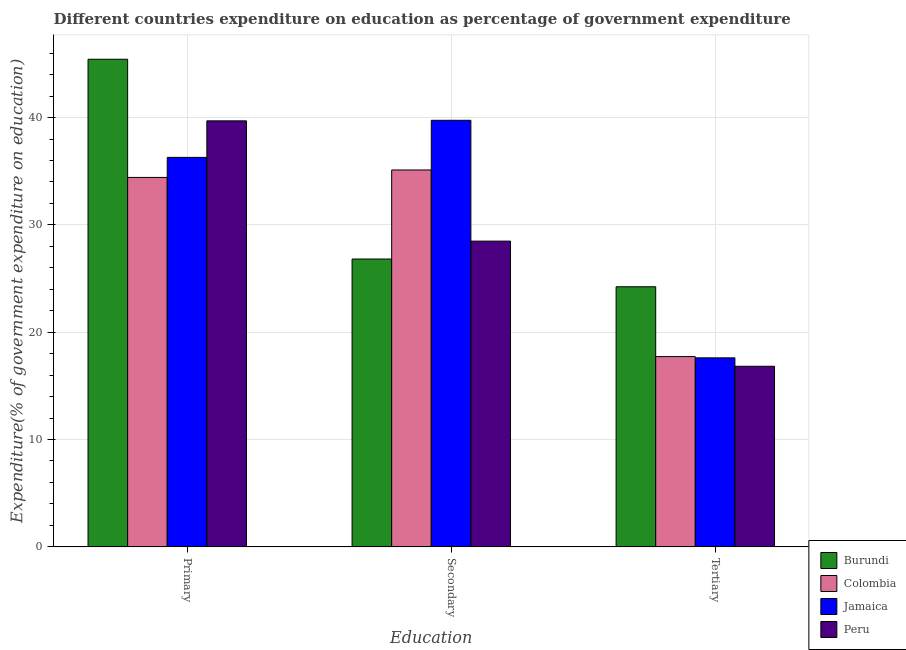How many different coloured bars are there?
Make the answer very short. 4. Are the number of bars on each tick of the X-axis equal?
Give a very brief answer. Yes. How many bars are there on the 3rd tick from the left?
Your response must be concise. 4. What is the label of the 3rd group of bars from the left?
Your answer should be compact. Tertiary. What is the expenditure on tertiary education in Peru?
Your answer should be very brief. 16.82. Across all countries, what is the maximum expenditure on primary education?
Your response must be concise. 45.43. Across all countries, what is the minimum expenditure on secondary education?
Provide a short and direct response. 26.82. In which country was the expenditure on tertiary education maximum?
Make the answer very short. Burundi. What is the total expenditure on primary education in the graph?
Give a very brief answer. 155.83. What is the difference between the expenditure on primary education in Colombia and that in Burundi?
Offer a very short reply. -11.01. What is the difference between the expenditure on tertiary education in Jamaica and the expenditure on primary education in Colombia?
Your answer should be very brief. -16.81. What is the average expenditure on primary education per country?
Ensure brevity in your answer.  38.96. What is the difference between the expenditure on primary education and expenditure on secondary education in Colombia?
Offer a very short reply. -0.69. What is the ratio of the expenditure on primary education in Colombia to that in Jamaica?
Offer a very short reply. 0.95. Is the expenditure on tertiary education in Colombia less than that in Burundi?
Keep it short and to the point. Yes. Is the difference between the expenditure on primary education in Peru and Burundi greater than the difference between the expenditure on tertiary education in Peru and Burundi?
Your answer should be compact. Yes. What is the difference between the highest and the second highest expenditure on primary education?
Offer a very short reply. 5.74. What is the difference between the highest and the lowest expenditure on secondary education?
Offer a terse response. 12.93. Is the sum of the expenditure on tertiary education in Burundi and Peru greater than the maximum expenditure on primary education across all countries?
Provide a succinct answer. No. What does the 4th bar from the left in Secondary represents?
Offer a terse response. Peru. What does the 2nd bar from the right in Tertiary represents?
Keep it short and to the point. Jamaica. How many countries are there in the graph?
Offer a very short reply. 4. Does the graph contain any zero values?
Your answer should be very brief. No. How are the legend labels stacked?
Give a very brief answer. Vertical. What is the title of the graph?
Make the answer very short. Different countries expenditure on education as percentage of government expenditure. What is the label or title of the X-axis?
Provide a short and direct response. Education. What is the label or title of the Y-axis?
Keep it short and to the point. Expenditure(% of government expenditure on education). What is the Expenditure(% of government expenditure on education) in Burundi in Primary?
Your response must be concise. 45.43. What is the Expenditure(% of government expenditure on education) in Colombia in Primary?
Provide a succinct answer. 34.42. What is the Expenditure(% of government expenditure on education) in Jamaica in Primary?
Provide a short and direct response. 36.29. What is the Expenditure(% of government expenditure on education) of Peru in Primary?
Provide a short and direct response. 39.69. What is the Expenditure(% of government expenditure on education) of Burundi in Secondary?
Offer a terse response. 26.82. What is the Expenditure(% of government expenditure on education) in Colombia in Secondary?
Offer a terse response. 35.11. What is the Expenditure(% of government expenditure on education) of Jamaica in Secondary?
Offer a terse response. 39.74. What is the Expenditure(% of government expenditure on education) of Peru in Secondary?
Keep it short and to the point. 28.49. What is the Expenditure(% of government expenditure on education) of Burundi in Tertiary?
Make the answer very short. 24.23. What is the Expenditure(% of government expenditure on education) of Colombia in Tertiary?
Offer a very short reply. 17.73. What is the Expenditure(% of government expenditure on education) of Jamaica in Tertiary?
Your response must be concise. 17.61. What is the Expenditure(% of government expenditure on education) in Peru in Tertiary?
Your response must be concise. 16.82. Across all Education, what is the maximum Expenditure(% of government expenditure on education) in Burundi?
Give a very brief answer. 45.43. Across all Education, what is the maximum Expenditure(% of government expenditure on education) of Colombia?
Your answer should be compact. 35.11. Across all Education, what is the maximum Expenditure(% of government expenditure on education) in Jamaica?
Keep it short and to the point. 39.74. Across all Education, what is the maximum Expenditure(% of government expenditure on education) in Peru?
Your answer should be compact. 39.69. Across all Education, what is the minimum Expenditure(% of government expenditure on education) of Burundi?
Your answer should be very brief. 24.23. Across all Education, what is the minimum Expenditure(% of government expenditure on education) in Colombia?
Make the answer very short. 17.73. Across all Education, what is the minimum Expenditure(% of government expenditure on education) of Jamaica?
Offer a terse response. 17.61. Across all Education, what is the minimum Expenditure(% of government expenditure on education) of Peru?
Your answer should be compact. 16.82. What is the total Expenditure(% of government expenditure on education) in Burundi in the graph?
Make the answer very short. 96.48. What is the total Expenditure(% of government expenditure on education) of Colombia in the graph?
Your answer should be very brief. 87.26. What is the total Expenditure(% of government expenditure on education) of Jamaica in the graph?
Keep it short and to the point. 93.64. What is the total Expenditure(% of government expenditure on education) of Peru in the graph?
Provide a succinct answer. 85. What is the difference between the Expenditure(% of government expenditure on education) of Burundi in Primary and that in Secondary?
Offer a very short reply. 18.61. What is the difference between the Expenditure(% of government expenditure on education) in Colombia in Primary and that in Secondary?
Offer a terse response. -0.69. What is the difference between the Expenditure(% of government expenditure on education) in Jamaica in Primary and that in Secondary?
Keep it short and to the point. -3.46. What is the difference between the Expenditure(% of government expenditure on education) in Peru in Primary and that in Secondary?
Give a very brief answer. 11.2. What is the difference between the Expenditure(% of government expenditure on education) in Burundi in Primary and that in Tertiary?
Make the answer very short. 21.2. What is the difference between the Expenditure(% of government expenditure on education) of Colombia in Primary and that in Tertiary?
Make the answer very short. 16.69. What is the difference between the Expenditure(% of government expenditure on education) of Jamaica in Primary and that in Tertiary?
Provide a short and direct response. 18.68. What is the difference between the Expenditure(% of government expenditure on education) in Peru in Primary and that in Tertiary?
Provide a short and direct response. 22.87. What is the difference between the Expenditure(% of government expenditure on education) of Burundi in Secondary and that in Tertiary?
Give a very brief answer. 2.58. What is the difference between the Expenditure(% of government expenditure on education) in Colombia in Secondary and that in Tertiary?
Keep it short and to the point. 17.39. What is the difference between the Expenditure(% of government expenditure on education) of Jamaica in Secondary and that in Tertiary?
Your answer should be compact. 22.13. What is the difference between the Expenditure(% of government expenditure on education) of Peru in Secondary and that in Tertiary?
Provide a succinct answer. 11.66. What is the difference between the Expenditure(% of government expenditure on education) in Burundi in Primary and the Expenditure(% of government expenditure on education) in Colombia in Secondary?
Offer a very short reply. 10.32. What is the difference between the Expenditure(% of government expenditure on education) in Burundi in Primary and the Expenditure(% of government expenditure on education) in Jamaica in Secondary?
Keep it short and to the point. 5.69. What is the difference between the Expenditure(% of government expenditure on education) of Burundi in Primary and the Expenditure(% of government expenditure on education) of Peru in Secondary?
Your answer should be very brief. 16.94. What is the difference between the Expenditure(% of government expenditure on education) in Colombia in Primary and the Expenditure(% of government expenditure on education) in Jamaica in Secondary?
Offer a terse response. -5.32. What is the difference between the Expenditure(% of government expenditure on education) of Colombia in Primary and the Expenditure(% of government expenditure on education) of Peru in Secondary?
Your response must be concise. 5.93. What is the difference between the Expenditure(% of government expenditure on education) in Jamaica in Primary and the Expenditure(% of government expenditure on education) in Peru in Secondary?
Give a very brief answer. 7.8. What is the difference between the Expenditure(% of government expenditure on education) of Burundi in Primary and the Expenditure(% of government expenditure on education) of Colombia in Tertiary?
Keep it short and to the point. 27.7. What is the difference between the Expenditure(% of government expenditure on education) of Burundi in Primary and the Expenditure(% of government expenditure on education) of Jamaica in Tertiary?
Offer a terse response. 27.82. What is the difference between the Expenditure(% of government expenditure on education) of Burundi in Primary and the Expenditure(% of government expenditure on education) of Peru in Tertiary?
Your answer should be very brief. 28.61. What is the difference between the Expenditure(% of government expenditure on education) of Colombia in Primary and the Expenditure(% of government expenditure on education) of Jamaica in Tertiary?
Ensure brevity in your answer.  16.81. What is the difference between the Expenditure(% of government expenditure on education) of Colombia in Primary and the Expenditure(% of government expenditure on education) of Peru in Tertiary?
Give a very brief answer. 17.6. What is the difference between the Expenditure(% of government expenditure on education) of Jamaica in Primary and the Expenditure(% of government expenditure on education) of Peru in Tertiary?
Ensure brevity in your answer.  19.46. What is the difference between the Expenditure(% of government expenditure on education) in Burundi in Secondary and the Expenditure(% of government expenditure on education) in Colombia in Tertiary?
Your answer should be very brief. 9.09. What is the difference between the Expenditure(% of government expenditure on education) of Burundi in Secondary and the Expenditure(% of government expenditure on education) of Jamaica in Tertiary?
Give a very brief answer. 9.21. What is the difference between the Expenditure(% of government expenditure on education) in Burundi in Secondary and the Expenditure(% of government expenditure on education) in Peru in Tertiary?
Offer a terse response. 9.99. What is the difference between the Expenditure(% of government expenditure on education) in Colombia in Secondary and the Expenditure(% of government expenditure on education) in Jamaica in Tertiary?
Offer a terse response. 17.51. What is the difference between the Expenditure(% of government expenditure on education) in Colombia in Secondary and the Expenditure(% of government expenditure on education) in Peru in Tertiary?
Your answer should be compact. 18.29. What is the difference between the Expenditure(% of government expenditure on education) of Jamaica in Secondary and the Expenditure(% of government expenditure on education) of Peru in Tertiary?
Provide a short and direct response. 22.92. What is the average Expenditure(% of government expenditure on education) of Burundi per Education?
Provide a succinct answer. 32.16. What is the average Expenditure(% of government expenditure on education) of Colombia per Education?
Provide a succinct answer. 29.09. What is the average Expenditure(% of government expenditure on education) of Jamaica per Education?
Ensure brevity in your answer.  31.21. What is the average Expenditure(% of government expenditure on education) in Peru per Education?
Your answer should be compact. 28.33. What is the difference between the Expenditure(% of government expenditure on education) of Burundi and Expenditure(% of government expenditure on education) of Colombia in Primary?
Make the answer very short. 11.01. What is the difference between the Expenditure(% of government expenditure on education) of Burundi and Expenditure(% of government expenditure on education) of Jamaica in Primary?
Offer a very short reply. 9.14. What is the difference between the Expenditure(% of government expenditure on education) in Burundi and Expenditure(% of government expenditure on education) in Peru in Primary?
Your answer should be compact. 5.74. What is the difference between the Expenditure(% of government expenditure on education) of Colombia and Expenditure(% of government expenditure on education) of Jamaica in Primary?
Keep it short and to the point. -1.87. What is the difference between the Expenditure(% of government expenditure on education) in Colombia and Expenditure(% of government expenditure on education) in Peru in Primary?
Give a very brief answer. -5.27. What is the difference between the Expenditure(% of government expenditure on education) of Jamaica and Expenditure(% of government expenditure on education) of Peru in Primary?
Provide a short and direct response. -3.4. What is the difference between the Expenditure(% of government expenditure on education) in Burundi and Expenditure(% of government expenditure on education) in Colombia in Secondary?
Your answer should be compact. -8.3. What is the difference between the Expenditure(% of government expenditure on education) of Burundi and Expenditure(% of government expenditure on education) of Jamaica in Secondary?
Make the answer very short. -12.93. What is the difference between the Expenditure(% of government expenditure on education) in Burundi and Expenditure(% of government expenditure on education) in Peru in Secondary?
Your answer should be compact. -1.67. What is the difference between the Expenditure(% of government expenditure on education) of Colombia and Expenditure(% of government expenditure on education) of Jamaica in Secondary?
Your answer should be very brief. -4.63. What is the difference between the Expenditure(% of government expenditure on education) in Colombia and Expenditure(% of government expenditure on education) in Peru in Secondary?
Offer a very short reply. 6.63. What is the difference between the Expenditure(% of government expenditure on education) in Jamaica and Expenditure(% of government expenditure on education) in Peru in Secondary?
Keep it short and to the point. 11.26. What is the difference between the Expenditure(% of government expenditure on education) in Burundi and Expenditure(% of government expenditure on education) in Colombia in Tertiary?
Offer a terse response. 6.51. What is the difference between the Expenditure(% of government expenditure on education) in Burundi and Expenditure(% of government expenditure on education) in Jamaica in Tertiary?
Ensure brevity in your answer.  6.62. What is the difference between the Expenditure(% of government expenditure on education) in Burundi and Expenditure(% of government expenditure on education) in Peru in Tertiary?
Offer a very short reply. 7.41. What is the difference between the Expenditure(% of government expenditure on education) of Colombia and Expenditure(% of government expenditure on education) of Jamaica in Tertiary?
Give a very brief answer. 0.12. What is the difference between the Expenditure(% of government expenditure on education) in Colombia and Expenditure(% of government expenditure on education) in Peru in Tertiary?
Your answer should be compact. 0.9. What is the difference between the Expenditure(% of government expenditure on education) of Jamaica and Expenditure(% of government expenditure on education) of Peru in Tertiary?
Offer a terse response. 0.78. What is the ratio of the Expenditure(% of government expenditure on education) of Burundi in Primary to that in Secondary?
Your answer should be very brief. 1.69. What is the ratio of the Expenditure(% of government expenditure on education) of Colombia in Primary to that in Secondary?
Provide a succinct answer. 0.98. What is the ratio of the Expenditure(% of government expenditure on education) of Peru in Primary to that in Secondary?
Offer a very short reply. 1.39. What is the ratio of the Expenditure(% of government expenditure on education) of Burundi in Primary to that in Tertiary?
Offer a terse response. 1.87. What is the ratio of the Expenditure(% of government expenditure on education) in Colombia in Primary to that in Tertiary?
Provide a succinct answer. 1.94. What is the ratio of the Expenditure(% of government expenditure on education) of Jamaica in Primary to that in Tertiary?
Provide a short and direct response. 2.06. What is the ratio of the Expenditure(% of government expenditure on education) in Peru in Primary to that in Tertiary?
Your answer should be compact. 2.36. What is the ratio of the Expenditure(% of government expenditure on education) in Burundi in Secondary to that in Tertiary?
Offer a very short reply. 1.11. What is the ratio of the Expenditure(% of government expenditure on education) in Colombia in Secondary to that in Tertiary?
Your response must be concise. 1.98. What is the ratio of the Expenditure(% of government expenditure on education) of Jamaica in Secondary to that in Tertiary?
Your answer should be compact. 2.26. What is the ratio of the Expenditure(% of government expenditure on education) of Peru in Secondary to that in Tertiary?
Provide a short and direct response. 1.69. What is the difference between the highest and the second highest Expenditure(% of government expenditure on education) of Burundi?
Make the answer very short. 18.61. What is the difference between the highest and the second highest Expenditure(% of government expenditure on education) in Colombia?
Provide a short and direct response. 0.69. What is the difference between the highest and the second highest Expenditure(% of government expenditure on education) of Jamaica?
Provide a succinct answer. 3.46. What is the difference between the highest and the second highest Expenditure(% of government expenditure on education) of Peru?
Offer a terse response. 11.2. What is the difference between the highest and the lowest Expenditure(% of government expenditure on education) in Burundi?
Your answer should be very brief. 21.2. What is the difference between the highest and the lowest Expenditure(% of government expenditure on education) of Colombia?
Provide a succinct answer. 17.39. What is the difference between the highest and the lowest Expenditure(% of government expenditure on education) in Jamaica?
Provide a succinct answer. 22.13. What is the difference between the highest and the lowest Expenditure(% of government expenditure on education) of Peru?
Keep it short and to the point. 22.87. 